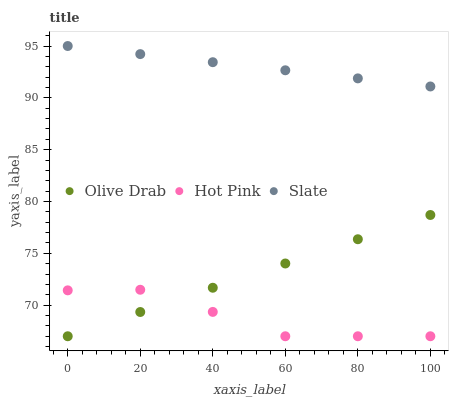Does Hot Pink have the minimum area under the curve?
Answer yes or no. Yes. Does Slate have the maximum area under the curve?
Answer yes or no. Yes. Does Olive Drab have the minimum area under the curve?
Answer yes or no. No. Does Olive Drab have the maximum area under the curve?
Answer yes or no. No. Is Olive Drab the smoothest?
Answer yes or no. Yes. Is Hot Pink the roughest?
Answer yes or no. Yes. Is Hot Pink the smoothest?
Answer yes or no. No. Is Olive Drab the roughest?
Answer yes or no. No. Does Hot Pink have the lowest value?
Answer yes or no. Yes. Does Slate have the highest value?
Answer yes or no. Yes. Does Olive Drab have the highest value?
Answer yes or no. No. Is Hot Pink less than Slate?
Answer yes or no. Yes. Is Slate greater than Olive Drab?
Answer yes or no. Yes. Does Olive Drab intersect Hot Pink?
Answer yes or no. Yes. Is Olive Drab less than Hot Pink?
Answer yes or no. No. Is Olive Drab greater than Hot Pink?
Answer yes or no. No. Does Hot Pink intersect Slate?
Answer yes or no. No. 